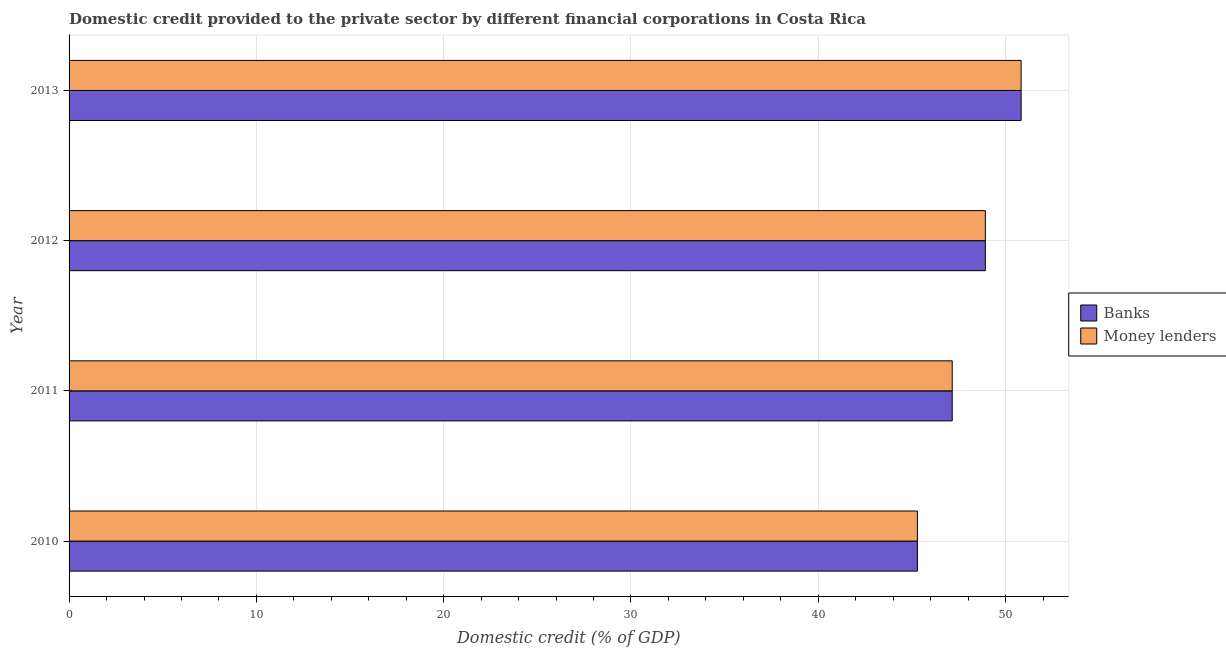How many different coloured bars are there?
Provide a succinct answer. 2. How many groups of bars are there?
Give a very brief answer. 4. Are the number of bars on each tick of the Y-axis equal?
Offer a very short reply. Yes. In how many cases, is the number of bars for a given year not equal to the number of legend labels?
Ensure brevity in your answer.  0. What is the domestic credit provided by money lenders in 2013?
Your answer should be compact. 50.83. Across all years, what is the maximum domestic credit provided by banks?
Your response must be concise. 50.83. Across all years, what is the minimum domestic credit provided by banks?
Keep it short and to the point. 45.29. In which year was the domestic credit provided by money lenders maximum?
Offer a terse response. 2013. In which year was the domestic credit provided by money lenders minimum?
Ensure brevity in your answer.  2010. What is the total domestic credit provided by money lenders in the graph?
Offer a terse response. 192.19. What is the difference between the domestic credit provided by banks in 2010 and that in 2013?
Your response must be concise. -5.54. What is the difference between the domestic credit provided by banks in 2011 and the domestic credit provided by money lenders in 2010?
Offer a terse response. 1.86. What is the average domestic credit provided by money lenders per year?
Give a very brief answer. 48.05. What is the ratio of the domestic credit provided by banks in 2010 to that in 2013?
Provide a succinct answer. 0.89. Is the domestic credit provided by banks in 2010 less than that in 2013?
Provide a short and direct response. Yes. Is the difference between the domestic credit provided by money lenders in 2010 and 2012 greater than the difference between the domestic credit provided by banks in 2010 and 2012?
Provide a short and direct response. No. What is the difference between the highest and the second highest domestic credit provided by banks?
Your answer should be very brief. 1.91. What is the difference between the highest and the lowest domestic credit provided by money lenders?
Make the answer very short. 5.54. In how many years, is the domestic credit provided by banks greater than the average domestic credit provided by banks taken over all years?
Provide a short and direct response. 2. What does the 2nd bar from the top in 2011 represents?
Give a very brief answer. Banks. What does the 2nd bar from the bottom in 2012 represents?
Provide a short and direct response. Money lenders. How many bars are there?
Make the answer very short. 8. Are all the bars in the graph horizontal?
Offer a very short reply. Yes. How many years are there in the graph?
Your answer should be very brief. 4. What is the difference between two consecutive major ticks on the X-axis?
Keep it short and to the point. 10. Are the values on the major ticks of X-axis written in scientific E-notation?
Your answer should be compact. No. Does the graph contain grids?
Your answer should be compact. Yes. What is the title of the graph?
Your answer should be very brief. Domestic credit provided to the private sector by different financial corporations in Costa Rica. Does "Official aid received" appear as one of the legend labels in the graph?
Ensure brevity in your answer.  No. What is the label or title of the X-axis?
Provide a short and direct response. Domestic credit (% of GDP). What is the label or title of the Y-axis?
Offer a very short reply. Year. What is the Domestic credit (% of GDP) in Banks in 2010?
Provide a succinct answer. 45.29. What is the Domestic credit (% of GDP) in Money lenders in 2010?
Your answer should be compact. 45.29. What is the Domestic credit (% of GDP) of Banks in 2011?
Your answer should be very brief. 47.15. What is the Domestic credit (% of GDP) of Money lenders in 2011?
Your answer should be very brief. 47.15. What is the Domestic credit (% of GDP) in Banks in 2012?
Give a very brief answer. 48.92. What is the Domestic credit (% of GDP) in Money lenders in 2012?
Give a very brief answer. 48.92. What is the Domestic credit (% of GDP) of Banks in 2013?
Offer a terse response. 50.83. What is the Domestic credit (% of GDP) of Money lenders in 2013?
Give a very brief answer. 50.83. Across all years, what is the maximum Domestic credit (% of GDP) in Banks?
Keep it short and to the point. 50.83. Across all years, what is the maximum Domestic credit (% of GDP) in Money lenders?
Keep it short and to the point. 50.83. Across all years, what is the minimum Domestic credit (% of GDP) of Banks?
Give a very brief answer. 45.29. Across all years, what is the minimum Domestic credit (% of GDP) in Money lenders?
Offer a terse response. 45.29. What is the total Domestic credit (% of GDP) in Banks in the graph?
Your answer should be very brief. 192.19. What is the total Domestic credit (% of GDP) in Money lenders in the graph?
Make the answer very short. 192.19. What is the difference between the Domestic credit (% of GDP) in Banks in 2010 and that in 2011?
Provide a short and direct response. -1.86. What is the difference between the Domestic credit (% of GDP) of Money lenders in 2010 and that in 2011?
Offer a terse response. -1.86. What is the difference between the Domestic credit (% of GDP) in Banks in 2010 and that in 2012?
Give a very brief answer. -3.63. What is the difference between the Domestic credit (% of GDP) of Money lenders in 2010 and that in 2012?
Offer a terse response. -3.63. What is the difference between the Domestic credit (% of GDP) of Banks in 2010 and that in 2013?
Give a very brief answer. -5.54. What is the difference between the Domestic credit (% of GDP) of Money lenders in 2010 and that in 2013?
Your response must be concise. -5.54. What is the difference between the Domestic credit (% of GDP) of Banks in 2011 and that in 2012?
Keep it short and to the point. -1.77. What is the difference between the Domestic credit (% of GDP) of Money lenders in 2011 and that in 2012?
Provide a short and direct response. -1.77. What is the difference between the Domestic credit (% of GDP) of Banks in 2011 and that in 2013?
Give a very brief answer. -3.68. What is the difference between the Domestic credit (% of GDP) in Money lenders in 2011 and that in 2013?
Give a very brief answer. -3.68. What is the difference between the Domestic credit (% of GDP) of Banks in 2012 and that in 2013?
Give a very brief answer. -1.91. What is the difference between the Domestic credit (% of GDP) of Money lenders in 2012 and that in 2013?
Give a very brief answer. -1.91. What is the difference between the Domestic credit (% of GDP) in Banks in 2010 and the Domestic credit (% of GDP) in Money lenders in 2011?
Offer a very short reply. -1.86. What is the difference between the Domestic credit (% of GDP) of Banks in 2010 and the Domestic credit (% of GDP) of Money lenders in 2012?
Make the answer very short. -3.63. What is the difference between the Domestic credit (% of GDP) in Banks in 2010 and the Domestic credit (% of GDP) in Money lenders in 2013?
Provide a short and direct response. -5.54. What is the difference between the Domestic credit (% of GDP) in Banks in 2011 and the Domestic credit (% of GDP) in Money lenders in 2012?
Keep it short and to the point. -1.77. What is the difference between the Domestic credit (% of GDP) of Banks in 2011 and the Domestic credit (% of GDP) of Money lenders in 2013?
Offer a very short reply. -3.68. What is the difference between the Domestic credit (% of GDP) in Banks in 2012 and the Domestic credit (% of GDP) in Money lenders in 2013?
Offer a terse response. -1.91. What is the average Domestic credit (% of GDP) in Banks per year?
Provide a succinct answer. 48.05. What is the average Domestic credit (% of GDP) in Money lenders per year?
Ensure brevity in your answer.  48.05. In the year 2010, what is the difference between the Domestic credit (% of GDP) in Banks and Domestic credit (% of GDP) in Money lenders?
Offer a terse response. 0. What is the ratio of the Domestic credit (% of GDP) of Banks in 2010 to that in 2011?
Keep it short and to the point. 0.96. What is the ratio of the Domestic credit (% of GDP) of Money lenders in 2010 to that in 2011?
Give a very brief answer. 0.96. What is the ratio of the Domestic credit (% of GDP) in Banks in 2010 to that in 2012?
Your answer should be compact. 0.93. What is the ratio of the Domestic credit (% of GDP) of Money lenders in 2010 to that in 2012?
Keep it short and to the point. 0.93. What is the ratio of the Domestic credit (% of GDP) of Banks in 2010 to that in 2013?
Make the answer very short. 0.89. What is the ratio of the Domestic credit (% of GDP) of Money lenders in 2010 to that in 2013?
Offer a terse response. 0.89. What is the ratio of the Domestic credit (% of GDP) of Banks in 2011 to that in 2012?
Offer a terse response. 0.96. What is the ratio of the Domestic credit (% of GDP) in Money lenders in 2011 to that in 2012?
Offer a terse response. 0.96. What is the ratio of the Domestic credit (% of GDP) of Banks in 2011 to that in 2013?
Make the answer very short. 0.93. What is the ratio of the Domestic credit (% of GDP) of Money lenders in 2011 to that in 2013?
Offer a terse response. 0.93. What is the ratio of the Domestic credit (% of GDP) in Banks in 2012 to that in 2013?
Ensure brevity in your answer.  0.96. What is the ratio of the Domestic credit (% of GDP) of Money lenders in 2012 to that in 2013?
Offer a terse response. 0.96. What is the difference between the highest and the second highest Domestic credit (% of GDP) in Banks?
Keep it short and to the point. 1.91. What is the difference between the highest and the second highest Domestic credit (% of GDP) of Money lenders?
Provide a succinct answer. 1.91. What is the difference between the highest and the lowest Domestic credit (% of GDP) in Banks?
Your answer should be compact. 5.54. What is the difference between the highest and the lowest Domestic credit (% of GDP) in Money lenders?
Your response must be concise. 5.54. 